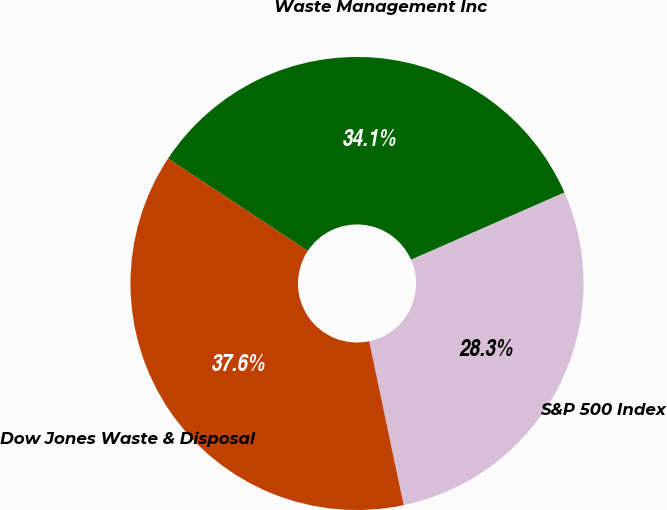Convert chart. <chart><loc_0><loc_0><loc_500><loc_500><pie_chart><fcel>Waste Management Inc<fcel>S&P 500 Index<fcel>Dow Jones Waste & Disposal<nl><fcel>34.13%<fcel>28.27%<fcel>37.6%<nl></chart> 